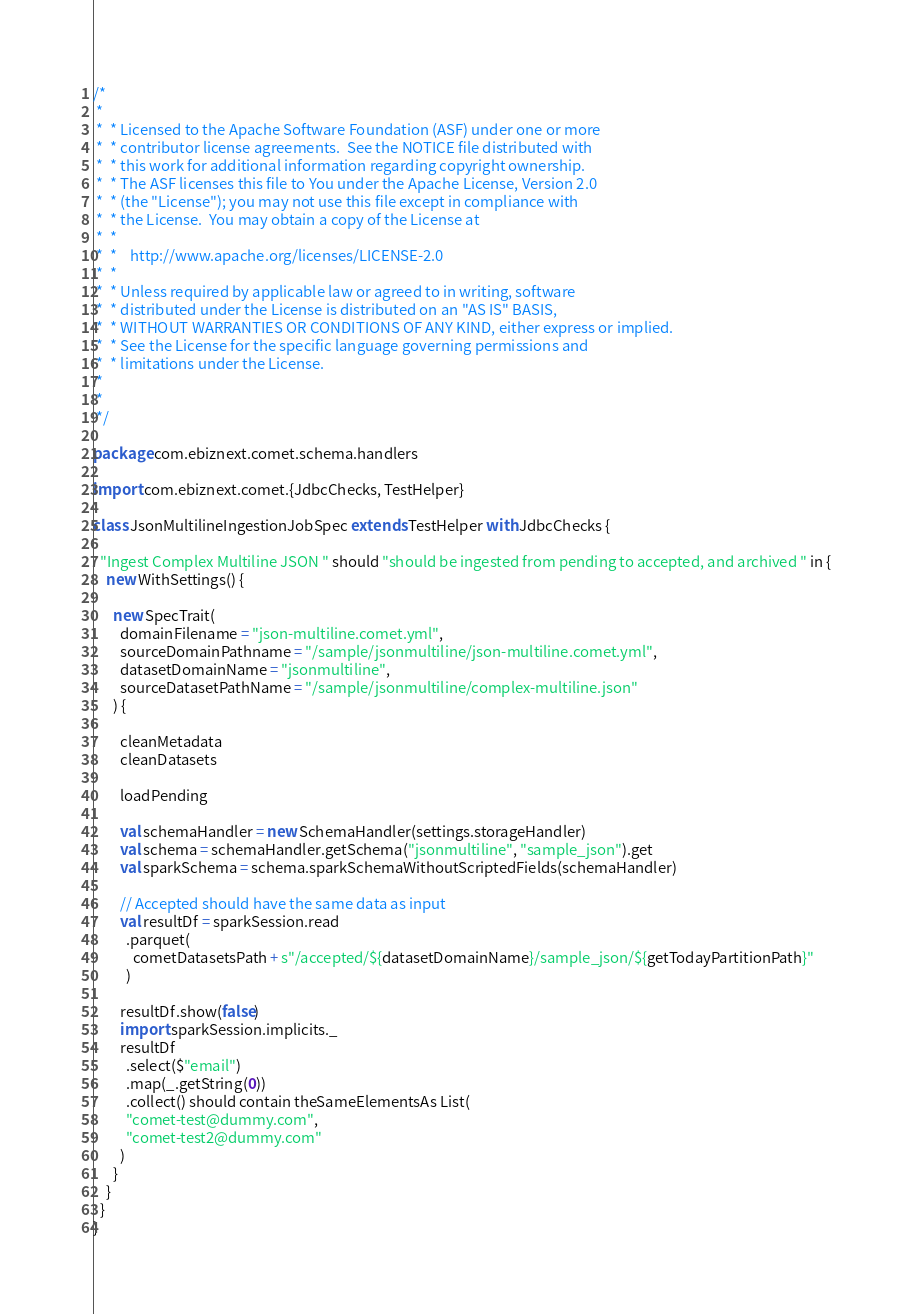Convert code to text. <code><loc_0><loc_0><loc_500><loc_500><_Scala_>/*
 *
 *  * Licensed to the Apache Software Foundation (ASF) under one or more
 *  * contributor license agreements.  See the NOTICE file distributed with
 *  * this work for additional information regarding copyright ownership.
 *  * The ASF licenses this file to You under the Apache License, Version 2.0
 *  * (the "License"); you may not use this file except in compliance with
 *  * the License.  You may obtain a copy of the License at
 *  *
 *  *    http://www.apache.org/licenses/LICENSE-2.0
 *  *
 *  * Unless required by applicable law or agreed to in writing, software
 *  * distributed under the License is distributed on an "AS IS" BASIS,
 *  * WITHOUT WARRANTIES OR CONDITIONS OF ANY KIND, either express or implied.
 *  * See the License for the specific language governing permissions and
 *  * limitations under the License.
 *
 *
 */

package com.ebiznext.comet.schema.handlers

import com.ebiznext.comet.{JdbcChecks, TestHelper}

class JsonMultilineIngestionJobSpec extends TestHelper with JdbcChecks {

  "Ingest Complex Multiline JSON " should "should be ingested from pending to accepted, and archived " in {
    new WithSettings() {

      new SpecTrait(
        domainFilename = "json-multiline.comet.yml",
        sourceDomainPathname = "/sample/jsonmultiline/json-multiline.comet.yml",
        datasetDomainName = "jsonmultiline",
        sourceDatasetPathName = "/sample/jsonmultiline/complex-multiline.json"
      ) {

        cleanMetadata
        cleanDatasets

        loadPending

        val schemaHandler = new SchemaHandler(settings.storageHandler)
        val schema = schemaHandler.getSchema("jsonmultiline", "sample_json").get
        val sparkSchema = schema.sparkSchemaWithoutScriptedFields(schemaHandler)

        // Accepted should have the same data as input
        val resultDf = sparkSession.read
          .parquet(
            cometDatasetsPath + s"/accepted/${datasetDomainName}/sample_json/${getTodayPartitionPath}"
          )

        resultDf.show(false)
        import sparkSession.implicits._
        resultDf
          .select($"email")
          .map(_.getString(0))
          .collect() should contain theSameElementsAs List(
          "comet-test@dummy.com",
          "comet-test2@dummy.com"
        )
      }
    }
  }
}
</code> 